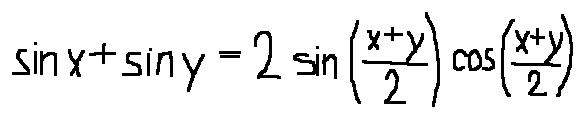Convert formula to latex. <formula><loc_0><loc_0><loc_500><loc_500>\sin x + \sin y = 2 \sin ( \frac { x + y } { 2 } ) \cos ( \frac { x + y } { 2 } )</formula> 